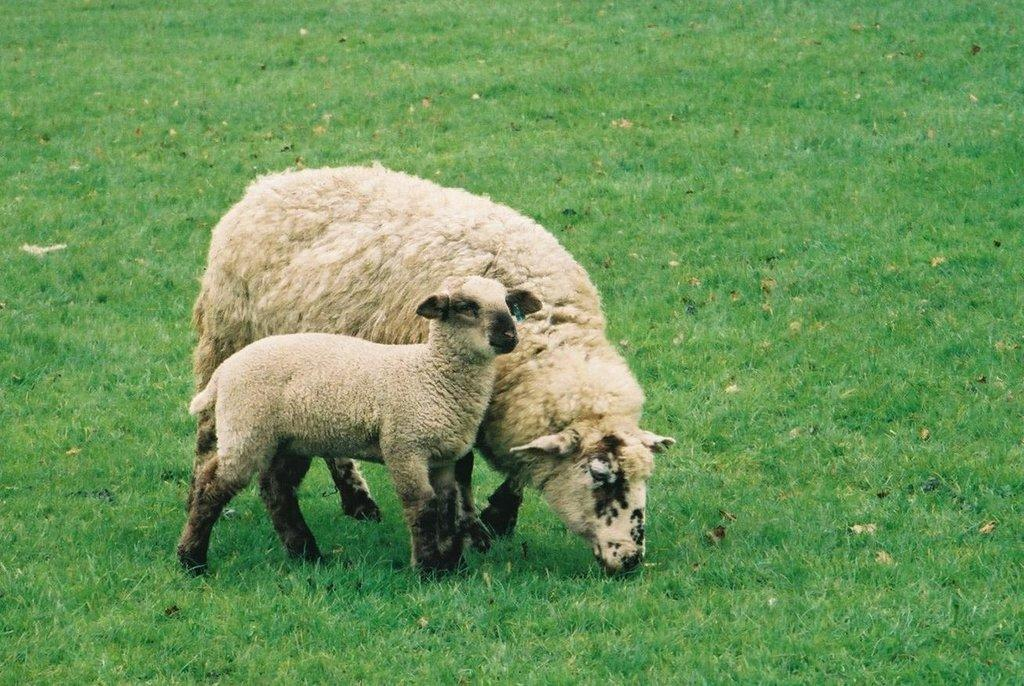What animals are present in the image? There are two sheep in the image. What is the sheep standing on? The sheep are standing on the surface of the grass. What invention can be seen in the image? There is no invention present in the image; it features two sheep standing on grass. What type of beef is visible in the image? There is no beef present in the image; it features two sheep standing on grass. 